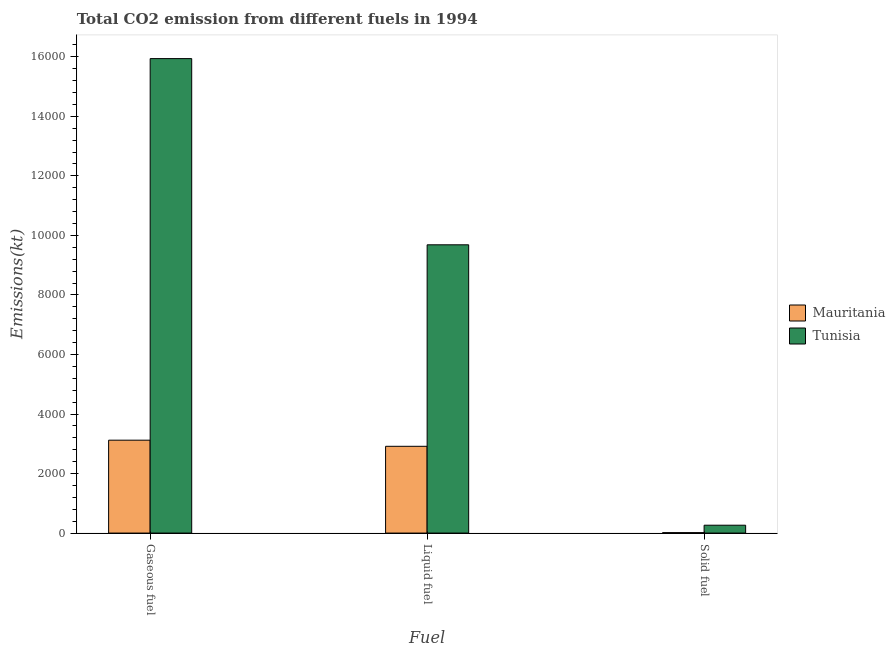How many different coloured bars are there?
Give a very brief answer. 2. How many groups of bars are there?
Your answer should be compact. 3. Are the number of bars per tick equal to the number of legend labels?
Offer a very short reply. Yes. Are the number of bars on each tick of the X-axis equal?
Offer a very short reply. Yes. How many bars are there on the 2nd tick from the left?
Your answer should be compact. 2. What is the label of the 2nd group of bars from the left?
Provide a short and direct response. Liquid fuel. What is the amount of co2 emissions from gaseous fuel in Tunisia?
Keep it short and to the point. 1.59e+04. Across all countries, what is the maximum amount of co2 emissions from liquid fuel?
Provide a succinct answer. 9684.55. Across all countries, what is the minimum amount of co2 emissions from liquid fuel?
Ensure brevity in your answer.  2915.26. In which country was the amount of co2 emissions from gaseous fuel maximum?
Offer a terse response. Tunisia. In which country was the amount of co2 emissions from gaseous fuel minimum?
Your answer should be compact. Mauritania. What is the total amount of co2 emissions from liquid fuel in the graph?
Provide a short and direct response. 1.26e+04. What is the difference between the amount of co2 emissions from gaseous fuel in Mauritania and that in Tunisia?
Provide a succinct answer. -1.28e+04. What is the difference between the amount of co2 emissions from solid fuel in Tunisia and the amount of co2 emissions from liquid fuel in Mauritania?
Give a very brief answer. -2651.24. What is the average amount of co2 emissions from gaseous fuel per country?
Your answer should be compact. 9530.53. What is the difference between the amount of co2 emissions from gaseous fuel and amount of co2 emissions from solid fuel in Tunisia?
Give a very brief answer. 1.57e+04. What is the ratio of the amount of co2 emissions from liquid fuel in Tunisia to that in Mauritania?
Provide a succinct answer. 3.32. What is the difference between the highest and the second highest amount of co2 emissions from gaseous fuel?
Offer a terse response. 1.28e+04. What is the difference between the highest and the lowest amount of co2 emissions from solid fuel?
Provide a succinct answer. 249.36. In how many countries, is the amount of co2 emissions from solid fuel greater than the average amount of co2 emissions from solid fuel taken over all countries?
Your answer should be very brief. 1. Is the sum of the amount of co2 emissions from liquid fuel in Mauritania and Tunisia greater than the maximum amount of co2 emissions from gaseous fuel across all countries?
Offer a terse response. No. What does the 2nd bar from the left in Solid fuel represents?
Offer a very short reply. Tunisia. What does the 1st bar from the right in Liquid fuel represents?
Offer a very short reply. Tunisia. Is it the case that in every country, the sum of the amount of co2 emissions from gaseous fuel and amount of co2 emissions from liquid fuel is greater than the amount of co2 emissions from solid fuel?
Provide a succinct answer. Yes. How many bars are there?
Provide a succinct answer. 6. Are all the bars in the graph horizontal?
Your response must be concise. No. How many countries are there in the graph?
Make the answer very short. 2. Are the values on the major ticks of Y-axis written in scientific E-notation?
Give a very brief answer. No. Does the graph contain grids?
Ensure brevity in your answer.  No. How many legend labels are there?
Make the answer very short. 2. How are the legend labels stacked?
Keep it short and to the point. Vertical. What is the title of the graph?
Your response must be concise. Total CO2 emission from different fuels in 1994. What is the label or title of the X-axis?
Make the answer very short. Fuel. What is the label or title of the Y-axis?
Provide a short and direct response. Emissions(kt). What is the Emissions(kt) in Mauritania in Gaseous fuel?
Provide a short and direct response. 3120.62. What is the Emissions(kt) of Tunisia in Gaseous fuel?
Ensure brevity in your answer.  1.59e+04. What is the Emissions(kt) of Mauritania in Liquid fuel?
Your response must be concise. 2915.26. What is the Emissions(kt) of Tunisia in Liquid fuel?
Make the answer very short. 9684.55. What is the Emissions(kt) in Mauritania in Solid fuel?
Your answer should be very brief. 14.67. What is the Emissions(kt) in Tunisia in Solid fuel?
Offer a very short reply. 264.02. Across all Fuel, what is the maximum Emissions(kt) of Mauritania?
Ensure brevity in your answer.  3120.62. Across all Fuel, what is the maximum Emissions(kt) of Tunisia?
Give a very brief answer. 1.59e+04. Across all Fuel, what is the minimum Emissions(kt) of Mauritania?
Provide a short and direct response. 14.67. Across all Fuel, what is the minimum Emissions(kt) in Tunisia?
Your answer should be compact. 264.02. What is the total Emissions(kt) in Mauritania in the graph?
Your response must be concise. 6050.55. What is the total Emissions(kt) in Tunisia in the graph?
Offer a terse response. 2.59e+04. What is the difference between the Emissions(kt) of Mauritania in Gaseous fuel and that in Liquid fuel?
Your answer should be very brief. 205.35. What is the difference between the Emissions(kt) in Tunisia in Gaseous fuel and that in Liquid fuel?
Keep it short and to the point. 6255.9. What is the difference between the Emissions(kt) of Mauritania in Gaseous fuel and that in Solid fuel?
Keep it short and to the point. 3105.95. What is the difference between the Emissions(kt) of Tunisia in Gaseous fuel and that in Solid fuel?
Give a very brief answer. 1.57e+04. What is the difference between the Emissions(kt) of Mauritania in Liquid fuel and that in Solid fuel?
Ensure brevity in your answer.  2900.6. What is the difference between the Emissions(kt) of Tunisia in Liquid fuel and that in Solid fuel?
Give a very brief answer. 9420.52. What is the difference between the Emissions(kt) of Mauritania in Gaseous fuel and the Emissions(kt) of Tunisia in Liquid fuel?
Your answer should be compact. -6563.93. What is the difference between the Emissions(kt) in Mauritania in Gaseous fuel and the Emissions(kt) in Tunisia in Solid fuel?
Give a very brief answer. 2856.59. What is the difference between the Emissions(kt) in Mauritania in Liquid fuel and the Emissions(kt) in Tunisia in Solid fuel?
Offer a terse response. 2651.24. What is the average Emissions(kt) in Mauritania per Fuel?
Ensure brevity in your answer.  2016.85. What is the average Emissions(kt) in Tunisia per Fuel?
Your answer should be compact. 8629.67. What is the difference between the Emissions(kt) of Mauritania and Emissions(kt) of Tunisia in Gaseous fuel?
Make the answer very short. -1.28e+04. What is the difference between the Emissions(kt) in Mauritania and Emissions(kt) in Tunisia in Liquid fuel?
Make the answer very short. -6769.28. What is the difference between the Emissions(kt) of Mauritania and Emissions(kt) of Tunisia in Solid fuel?
Give a very brief answer. -249.36. What is the ratio of the Emissions(kt) in Mauritania in Gaseous fuel to that in Liquid fuel?
Your response must be concise. 1.07. What is the ratio of the Emissions(kt) in Tunisia in Gaseous fuel to that in Liquid fuel?
Your response must be concise. 1.65. What is the ratio of the Emissions(kt) in Mauritania in Gaseous fuel to that in Solid fuel?
Provide a short and direct response. 212.75. What is the ratio of the Emissions(kt) of Tunisia in Gaseous fuel to that in Solid fuel?
Your answer should be very brief. 60.38. What is the ratio of the Emissions(kt) in Mauritania in Liquid fuel to that in Solid fuel?
Give a very brief answer. 198.75. What is the ratio of the Emissions(kt) in Tunisia in Liquid fuel to that in Solid fuel?
Offer a very short reply. 36.68. What is the difference between the highest and the second highest Emissions(kt) of Mauritania?
Provide a succinct answer. 205.35. What is the difference between the highest and the second highest Emissions(kt) of Tunisia?
Make the answer very short. 6255.9. What is the difference between the highest and the lowest Emissions(kt) in Mauritania?
Offer a very short reply. 3105.95. What is the difference between the highest and the lowest Emissions(kt) in Tunisia?
Make the answer very short. 1.57e+04. 